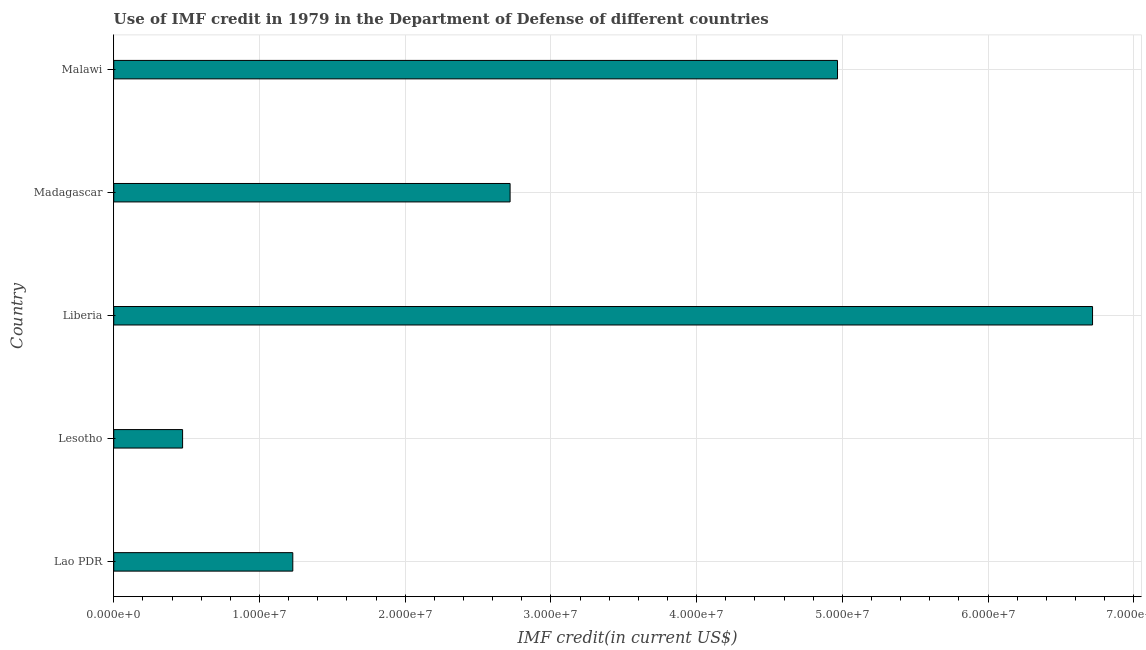Does the graph contain any zero values?
Ensure brevity in your answer.  No. Does the graph contain grids?
Offer a terse response. Yes. What is the title of the graph?
Offer a very short reply. Use of IMF credit in 1979 in the Department of Defense of different countries. What is the label or title of the X-axis?
Your answer should be very brief. IMF credit(in current US$). What is the label or title of the Y-axis?
Give a very brief answer. Country. What is the use of imf credit in dod in Malawi?
Make the answer very short. 4.97e+07. Across all countries, what is the maximum use of imf credit in dod?
Keep it short and to the point. 6.72e+07. Across all countries, what is the minimum use of imf credit in dod?
Make the answer very short. 4.72e+06. In which country was the use of imf credit in dod maximum?
Offer a very short reply. Liberia. In which country was the use of imf credit in dod minimum?
Ensure brevity in your answer.  Lesotho. What is the sum of the use of imf credit in dod?
Your answer should be compact. 1.61e+08. What is the difference between the use of imf credit in dod in Lesotho and Madagascar?
Offer a very short reply. -2.25e+07. What is the average use of imf credit in dod per country?
Give a very brief answer. 3.22e+07. What is the median use of imf credit in dod?
Your answer should be compact. 2.72e+07. In how many countries, is the use of imf credit in dod greater than 28000000 US$?
Offer a terse response. 2. What is the ratio of the use of imf credit in dod in Lesotho to that in Liberia?
Give a very brief answer. 0.07. Is the use of imf credit in dod in Lao PDR less than that in Malawi?
Offer a terse response. Yes. Is the difference between the use of imf credit in dod in Lao PDR and Lesotho greater than the difference between any two countries?
Provide a succinct answer. No. What is the difference between the highest and the second highest use of imf credit in dod?
Make the answer very short. 1.75e+07. Is the sum of the use of imf credit in dod in Lao PDR and Liberia greater than the maximum use of imf credit in dod across all countries?
Your answer should be very brief. Yes. What is the difference between the highest and the lowest use of imf credit in dod?
Provide a succinct answer. 6.24e+07. In how many countries, is the use of imf credit in dod greater than the average use of imf credit in dod taken over all countries?
Your response must be concise. 2. How many countries are there in the graph?
Ensure brevity in your answer.  5. What is the difference between two consecutive major ticks on the X-axis?
Offer a terse response. 1.00e+07. What is the IMF credit(in current US$) in Lao PDR?
Your answer should be compact. 1.23e+07. What is the IMF credit(in current US$) in Lesotho?
Ensure brevity in your answer.  4.72e+06. What is the IMF credit(in current US$) of Liberia?
Provide a short and direct response. 6.72e+07. What is the IMF credit(in current US$) of Madagascar?
Offer a terse response. 2.72e+07. What is the IMF credit(in current US$) of Malawi?
Offer a very short reply. 4.97e+07. What is the difference between the IMF credit(in current US$) in Lao PDR and Lesotho?
Provide a short and direct response. 7.56e+06. What is the difference between the IMF credit(in current US$) in Lao PDR and Liberia?
Keep it short and to the point. -5.49e+07. What is the difference between the IMF credit(in current US$) in Lao PDR and Madagascar?
Offer a terse response. -1.49e+07. What is the difference between the IMF credit(in current US$) in Lao PDR and Malawi?
Give a very brief answer. -3.74e+07. What is the difference between the IMF credit(in current US$) in Lesotho and Liberia?
Make the answer very short. -6.24e+07. What is the difference between the IMF credit(in current US$) in Lesotho and Madagascar?
Give a very brief answer. -2.25e+07. What is the difference between the IMF credit(in current US$) in Lesotho and Malawi?
Ensure brevity in your answer.  -4.49e+07. What is the difference between the IMF credit(in current US$) in Liberia and Madagascar?
Your answer should be very brief. 4.00e+07. What is the difference between the IMF credit(in current US$) in Liberia and Malawi?
Your answer should be compact. 1.75e+07. What is the difference between the IMF credit(in current US$) in Madagascar and Malawi?
Offer a terse response. -2.25e+07. What is the ratio of the IMF credit(in current US$) in Lao PDR to that in Liberia?
Offer a terse response. 0.18. What is the ratio of the IMF credit(in current US$) in Lao PDR to that in Madagascar?
Provide a succinct answer. 0.45. What is the ratio of the IMF credit(in current US$) in Lao PDR to that in Malawi?
Offer a very short reply. 0.25. What is the ratio of the IMF credit(in current US$) in Lesotho to that in Liberia?
Your response must be concise. 0.07. What is the ratio of the IMF credit(in current US$) in Lesotho to that in Madagascar?
Give a very brief answer. 0.17. What is the ratio of the IMF credit(in current US$) in Lesotho to that in Malawi?
Your answer should be very brief. 0.1. What is the ratio of the IMF credit(in current US$) in Liberia to that in Madagascar?
Ensure brevity in your answer.  2.47. What is the ratio of the IMF credit(in current US$) in Liberia to that in Malawi?
Provide a short and direct response. 1.35. What is the ratio of the IMF credit(in current US$) in Madagascar to that in Malawi?
Your answer should be very brief. 0.55. 